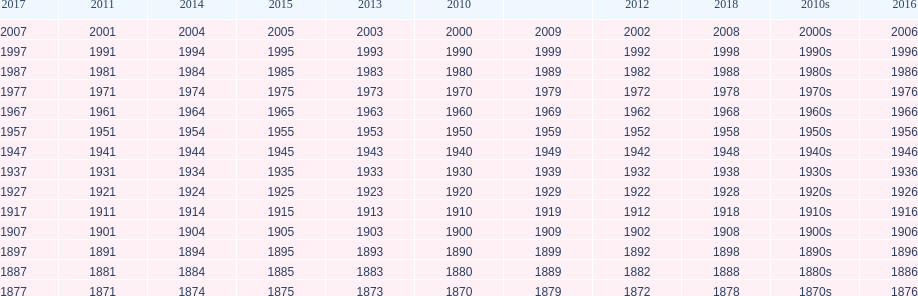What is the earliest year that a film was released? 1870. 